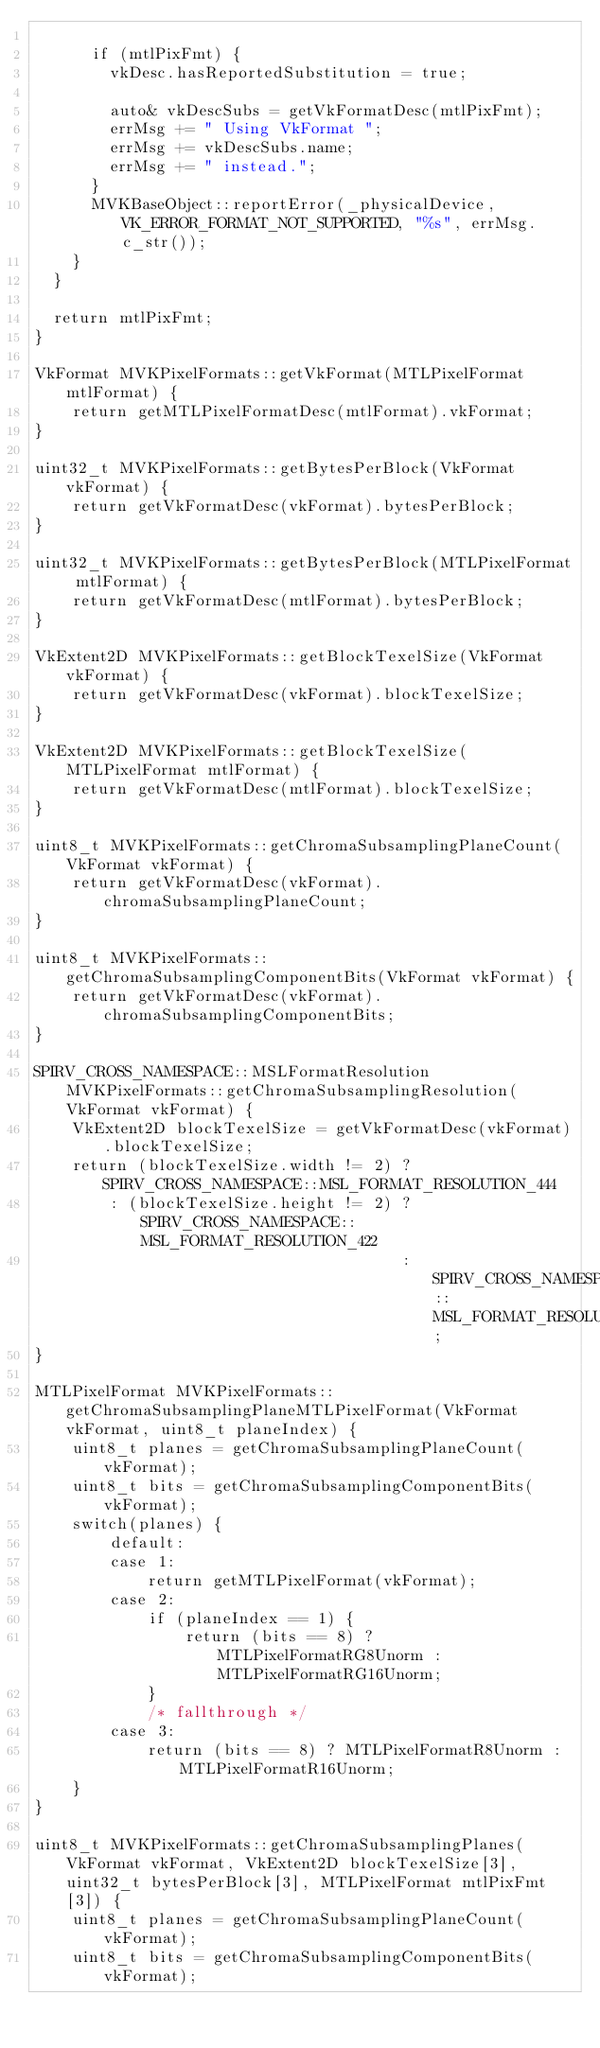<code> <loc_0><loc_0><loc_500><loc_500><_ObjectiveC_>
			if (mtlPixFmt) {
				vkDesc.hasReportedSubstitution = true;

				auto& vkDescSubs = getVkFormatDesc(mtlPixFmt);
				errMsg += " Using VkFormat ";
				errMsg += vkDescSubs.name;
				errMsg += " instead.";
			}
			MVKBaseObject::reportError(_physicalDevice, VK_ERROR_FORMAT_NOT_SUPPORTED, "%s", errMsg.c_str());
		}
	}

	return mtlPixFmt;
}

VkFormat MVKPixelFormats::getVkFormat(MTLPixelFormat mtlFormat) {
    return getMTLPixelFormatDesc(mtlFormat).vkFormat;
}

uint32_t MVKPixelFormats::getBytesPerBlock(VkFormat vkFormat) {
    return getVkFormatDesc(vkFormat).bytesPerBlock;
}

uint32_t MVKPixelFormats::getBytesPerBlock(MTLPixelFormat mtlFormat) {
    return getVkFormatDesc(mtlFormat).bytesPerBlock;
}

VkExtent2D MVKPixelFormats::getBlockTexelSize(VkFormat vkFormat) {
    return getVkFormatDesc(vkFormat).blockTexelSize;
}

VkExtent2D MVKPixelFormats::getBlockTexelSize(MTLPixelFormat mtlFormat) {
    return getVkFormatDesc(mtlFormat).blockTexelSize;
}

uint8_t MVKPixelFormats::getChromaSubsamplingPlaneCount(VkFormat vkFormat) {
    return getVkFormatDesc(vkFormat).chromaSubsamplingPlaneCount;
}

uint8_t MVKPixelFormats::getChromaSubsamplingComponentBits(VkFormat vkFormat) {
    return getVkFormatDesc(vkFormat).chromaSubsamplingComponentBits;
}

SPIRV_CROSS_NAMESPACE::MSLFormatResolution MVKPixelFormats::getChromaSubsamplingResolution(VkFormat vkFormat) {
    VkExtent2D blockTexelSize = getVkFormatDesc(vkFormat).blockTexelSize;
    return (blockTexelSize.width != 2) ? SPIRV_CROSS_NAMESPACE::MSL_FORMAT_RESOLUTION_444
        : (blockTexelSize.height != 2) ? SPIRV_CROSS_NAMESPACE::MSL_FORMAT_RESOLUTION_422
                                       : SPIRV_CROSS_NAMESPACE::MSL_FORMAT_RESOLUTION_420;
}

MTLPixelFormat MVKPixelFormats::getChromaSubsamplingPlaneMTLPixelFormat(VkFormat vkFormat, uint8_t planeIndex) {
    uint8_t planes = getChromaSubsamplingPlaneCount(vkFormat);
    uint8_t bits = getChromaSubsamplingComponentBits(vkFormat);
    switch(planes) {
        default:
        case 1:
            return getMTLPixelFormat(vkFormat);
        case 2:
            if (planeIndex == 1) {
                return (bits == 8) ? MTLPixelFormatRG8Unorm : MTLPixelFormatRG16Unorm;
            }
            /* fallthrough */
        case 3:
            return (bits == 8) ? MTLPixelFormatR8Unorm : MTLPixelFormatR16Unorm;
    }
}

uint8_t MVKPixelFormats::getChromaSubsamplingPlanes(VkFormat vkFormat, VkExtent2D blockTexelSize[3], uint32_t bytesPerBlock[3], MTLPixelFormat mtlPixFmt[3]) {
    uint8_t planes = getChromaSubsamplingPlaneCount(vkFormat);
    uint8_t bits = getChromaSubsamplingComponentBits(vkFormat);</code> 